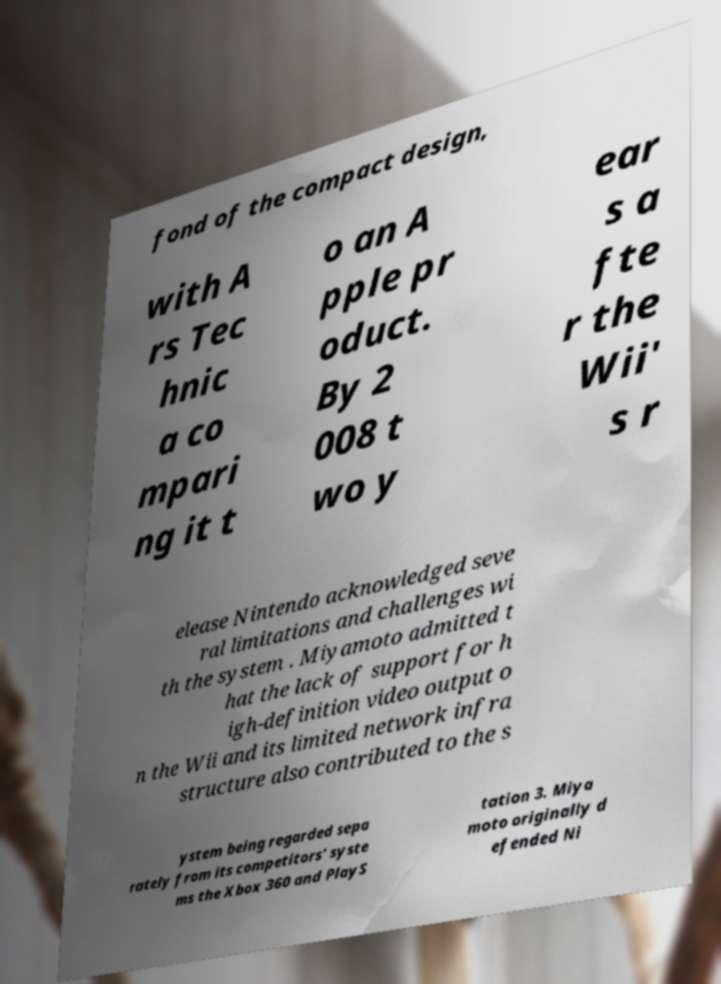Please identify and transcribe the text found in this image. fond of the compact design, with A rs Tec hnic a co mpari ng it t o an A pple pr oduct. By 2 008 t wo y ear s a fte r the Wii' s r elease Nintendo acknowledged seve ral limitations and challenges wi th the system . Miyamoto admitted t hat the lack of support for h igh-definition video output o n the Wii and its limited network infra structure also contributed to the s ystem being regarded sepa rately from its competitors' syste ms the Xbox 360 and PlayS tation 3. Miya moto originally d efended Ni 